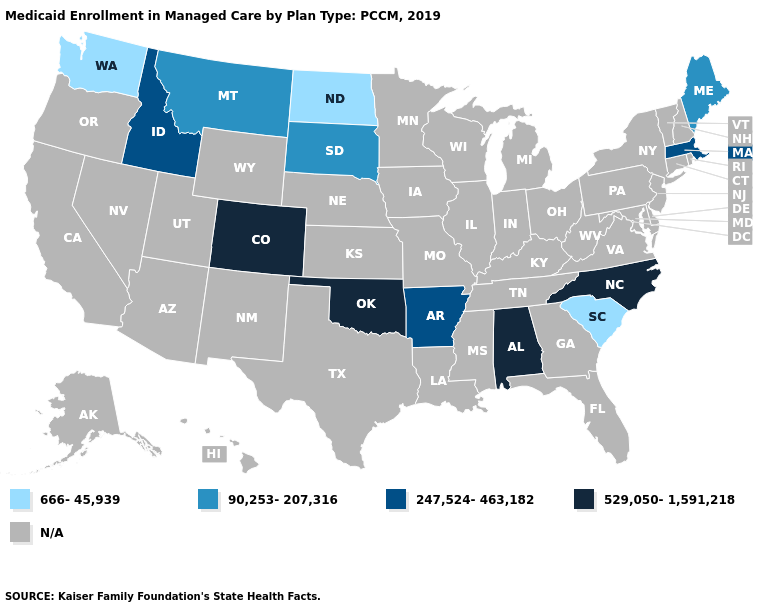Which states have the highest value in the USA?
Concise answer only. Alabama, Colorado, North Carolina, Oklahoma. Which states hav the highest value in the Northeast?
Be succinct. Massachusetts. What is the value of Illinois?
Quick response, please. N/A. Name the states that have a value in the range 666-45,939?
Keep it brief. North Dakota, South Carolina, Washington. What is the highest value in the USA?
Answer briefly. 529,050-1,591,218. Name the states that have a value in the range 529,050-1,591,218?
Concise answer only. Alabama, Colorado, North Carolina, Oklahoma. Does the first symbol in the legend represent the smallest category?
Answer briefly. Yes. Name the states that have a value in the range 247,524-463,182?
Answer briefly. Arkansas, Idaho, Massachusetts. Does Maine have the lowest value in the Northeast?
Short answer required. Yes. What is the highest value in the USA?
Write a very short answer. 529,050-1,591,218. Name the states that have a value in the range 666-45,939?
Answer briefly. North Dakota, South Carolina, Washington. What is the value of Hawaii?
Keep it brief. N/A. Name the states that have a value in the range 90,253-207,316?
Concise answer only. Maine, Montana, South Dakota. Name the states that have a value in the range 666-45,939?
Give a very brief answer. North Dakota, South Carolina, Washington. Name the states that have a value in the range 666-45,939?
Quick response, please. North Dakota, South Carolina, Washington. 